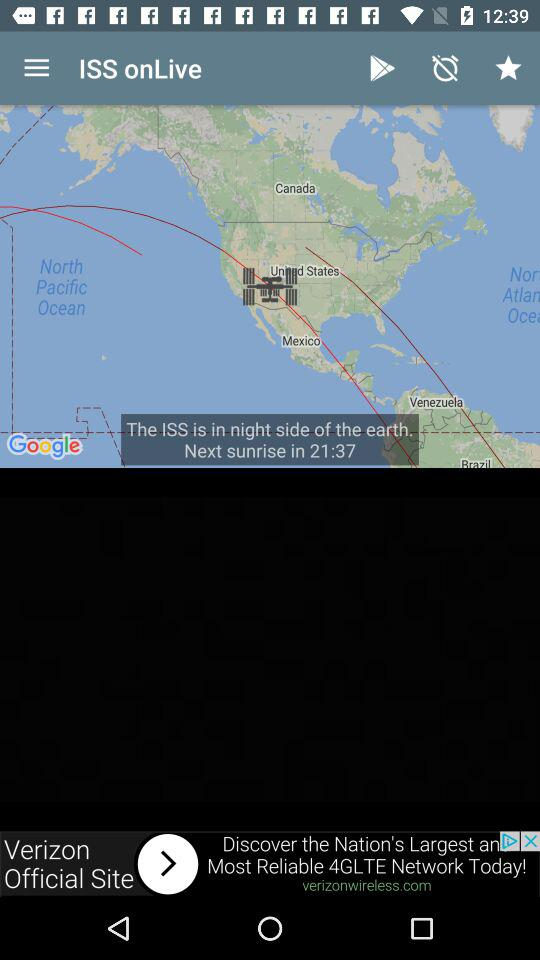What is the remaining time until the next sunrise? The remaining time until the next sunrise is 21:37. 